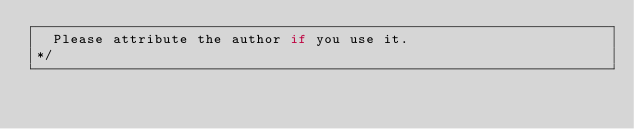<code> <loc_0><loc_0><loc_500><loc_500><_JavaScript_>	Please attribute the author if you use it.
*/</code> 